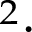Convert formula to latex. <formula><loc_0><loc_0><loc_500><loc_500>^ { 2 } \cdot</formula> 